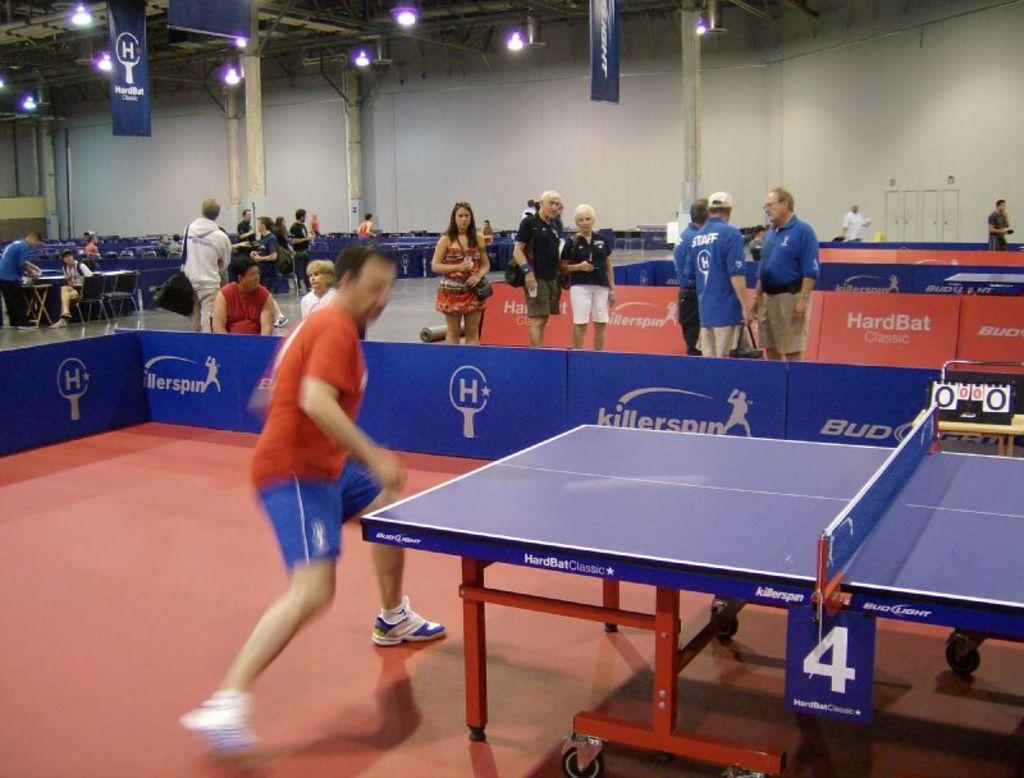Can you describe this image briefly? This image is in an indoor stadium, in front of the image there is a person playing table tennis, in front of the person there is the table, behind the person there are a few sponsor hoardings, behind the hoardings there are a few people standing and sitting in chairs and there are a few empty chairs and tables, in the background of the image there is a wall and there are a few banners hanging from the top of the ceiling with lamps beside them. 